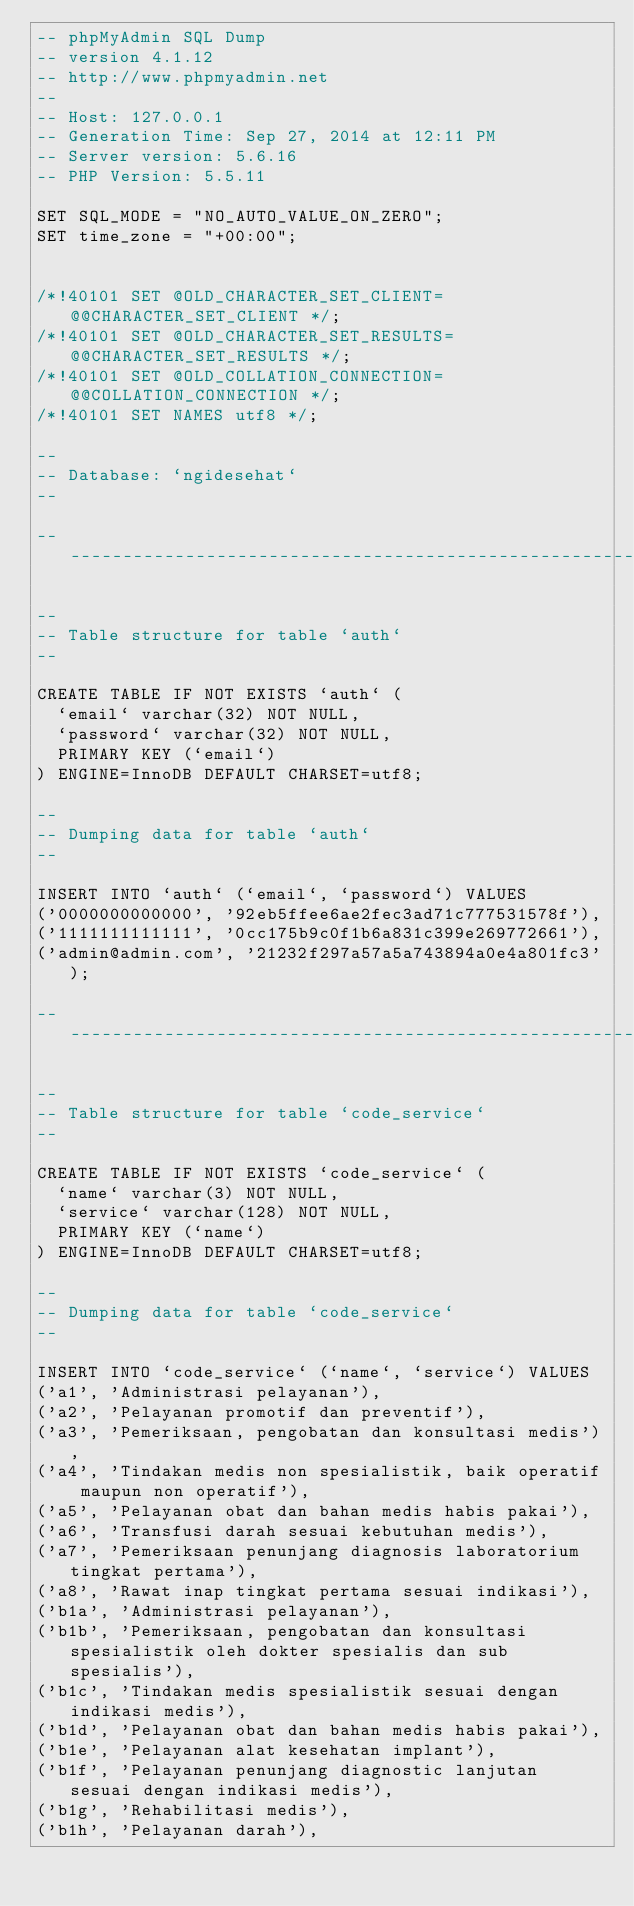<code> <loc_0><loc_0><loc_500><loc_500><_SQL_>-- phpMyAdmin SQL Dump
-- version 4.1.12
-- http://www.phpmyadmin.net
--
-- Host: 127.0.0.1
-- Generation Time: Sep 27, 2014 at 12:11 PM
-- Server version: 5.6.16
-- PHP Version: 5.5.11

SET SQL_MODE = "NO_AUTO_VALUE_ON_ZERO";
SET time_zone = "+00:00";


/*!40101 SET @OLD_CHARACTER_SET_CLIENT=@@CHARACTER_SET_CLIENT */;
/*!40101 SET @OLD_CHARACTER_SET_RESULTS=@@CHARACTER_SET_RESULTS */;
/*!40101 SET @OLD_COLLATION_CONNECTION=@@COLLATION_CONNECTION */;
/*!40101 SET NAMES utf8 */;

--
-- Database: `ngidesehat`
--

-- --------------------------------------------------------

--
-- Table structure for table `auth`
--

CREATE TABLE IF NOT EXISTS `auth` (
  `email` varchar(32) NOT NULL,
  `password` varchar(32) NOT NULL,
  PRIMARY KEY (`email`)
) ENGINE=InnoDB DEFAULT CHARSET=utf8;

--
-- Dumping data for table `auth`
--

INSERT INTO `auth` (`email`, `password`) VALUES
('0000000000000', '92eb5ffee6ae2fec3ad71c777531578f'),
('1111111111111', '0cc175b9c0f1b6a831c399e269772661'),
('admin@admin.com', '21232f297a57a5a743894a0e4a801fc3');

-- --------------------------------------------------------

--
-- Table structure for table `code_service`
--

CREATE TABLE IF NOT EXISTS `code_service` (
  `name` varchar(3) NOT NULL,
  `service` varchar(128) NOT NULL,
  PRIMARY KEY (`name`)
) ENGINE=InnoDB DEFAULT CHARSET=utf8;

--
-- Dumping data for table `code_service`
--

INSERT INTO `code_service` (`name`, `service`) VALUES
('a1', 'Administrasi pelayanan'),
('a2', 'Pelayanan promotif dan preventif'),
('a3', 'Pemeriksaan, pengobatan dan konsultasi medis'),
('a4', 'Tindakan medis non spesialistik, baik operatif maupun non operatif'),
('a5', 'Pelayanan obat dan bahan medis habis pakai'),
('a6', 'Transfusi darah sesuai kebutuhan medis'),
('a7', 'Pemeriksaan penunjang diagnosis laboratorium tingkat pertama'),
('a8', 'Rawat inap tingkat pertama sesuai indikasi'),
('b1a', 'Administrasi pelayanan'),
('b1b', 'Pemeriksaan, pengobatan dan konsultasi spesialistik oleh dokter spesialis dan sub spesialis'),
('b1c', 'Tindakan medis spesialistik sesuai dengan indikasi medis'),
('b1d', 'Pelayanan obat dan bahan medis habis pakai'),
('b1e', 'Pelayanan alat kesehatan implant'),
('b1f', 'Pelayanan penunjang diagnostic lanjutan sesuai dengan indikasi medis'),
('b1g', 'Rehabilitasi medis'),
('b1h', 'Pelayanan darah'),</code> 